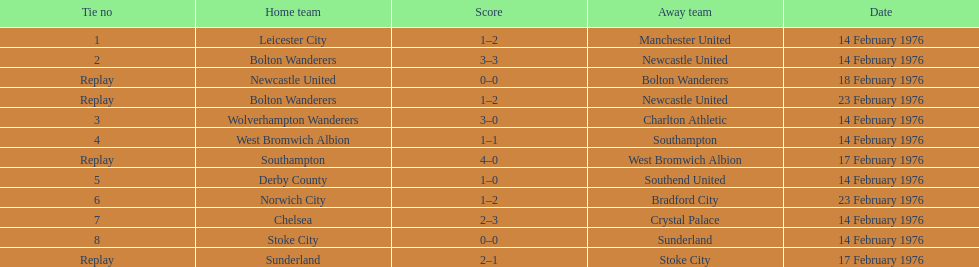Which squads participated the same day as leicester city and manchester united? Bolton Wanderers, Newcastle United. 